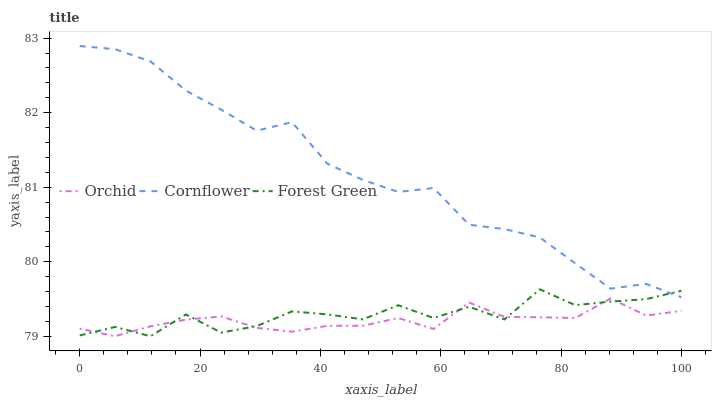Does Orchid have the minimum area under the curve?
Answer yes or no. Yes. Does Cornflower have the maximum area under the curve?
Answer yes or no. Yes. Does Forest Green have the minimum area under the curve?
Answer yes or no. No. Does Forest Green have the maximum area under the curve?
Answer yes or no. No. Is Orchid the smoothest?
Answer yes or no. Yes. Is Forest Green the roughest?
Answer yes or no. Yes. Is Forest Green the smoothest?
Answer yes or no. No. Is Orchid the roughest?
Answer yes or no. No. Does Forest Green have the lowest value?
Answer yes or no. Yes. Does Cornflower have the highest value?
Answer yes or no. Yes. Does Forest Green have the highest value?
Answer yes or no. No. Is Orchid less than Cornflower?
Answer yes or no. Yes. Is Cornflower greater than Orchid?
Answer yes or no. Yes. Does Cornflower intersect Forest Green?
Answer yes or no. Yes. Is Cornflower less than Forest Green?
Answer yes or no. No. Is Cornflower greater than Forest Green?
Answer yes or no. No. Does Orchid intersect Cornflower?
Answer yes or no. No. 